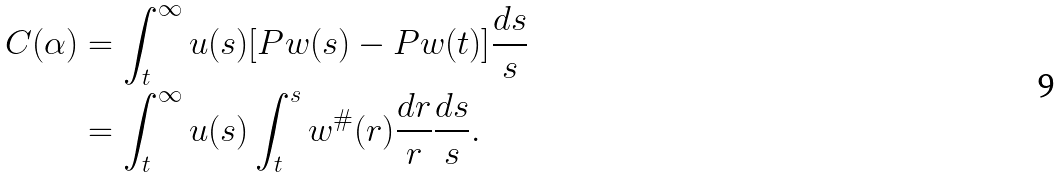Convert formula to latex. <formula><loc_0><loc_0><loc_500><loc_500>C ( \alpha ) & = \int _ { t } ^ { \infty } u ( s ) [ P w ( s ) - P w ( t ) ] \frac { d s } { s } \\ & = \int _ { t } ^ { \infty } u ( s ) \int _ { t } ^ { s } w ^ { \# } ( r ) \frac { d r } { r } \frac { d s } { s } .</formula> 